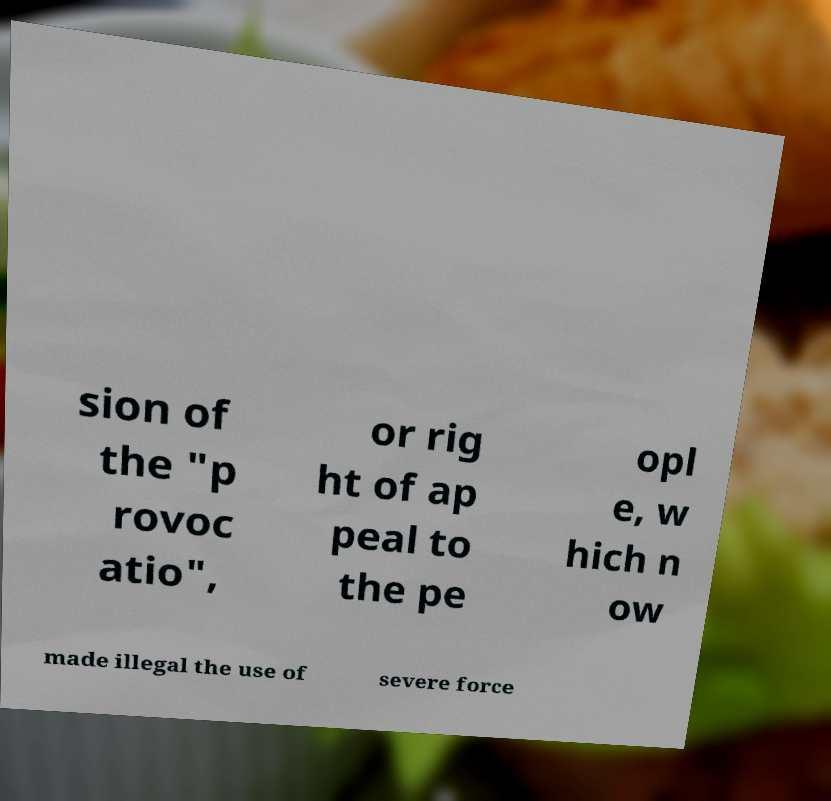Could you extract and type out the text from this image? sion of the "p rovoc atio", or rig ht of ap peal to the pe opl e, w hich n ow made illegal the use of severe force 